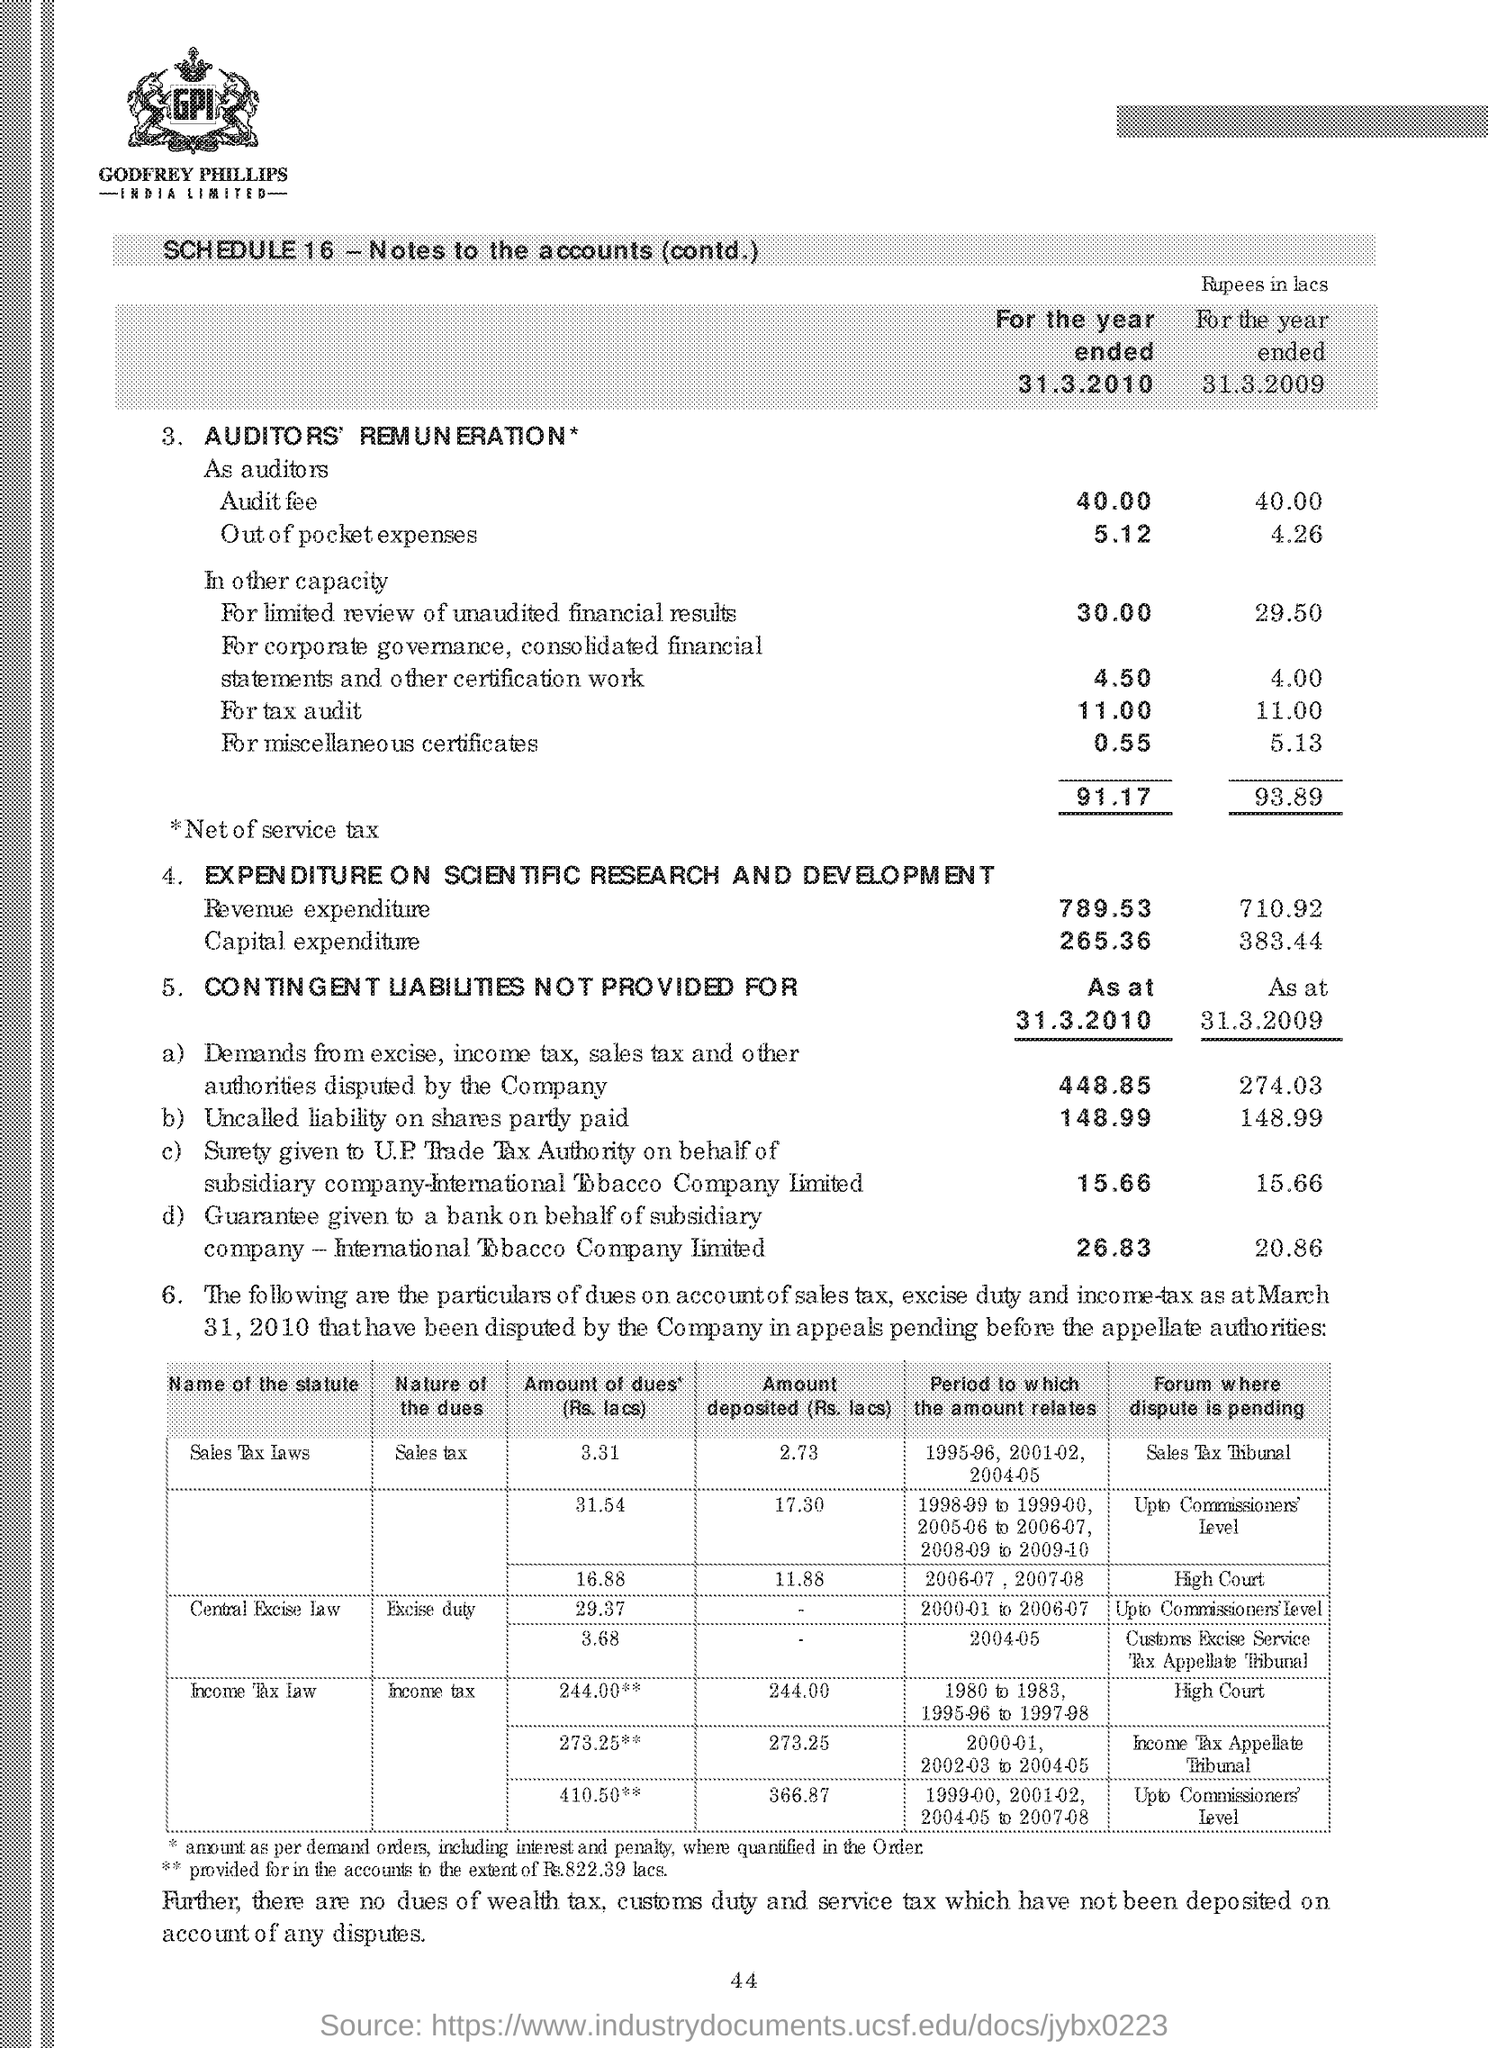What is the Nature of dues of Central Excise Law?
Your answer should be compact. Excise Duty. What is the number written at the bottom of the document?
Offer a terse response. 44. 